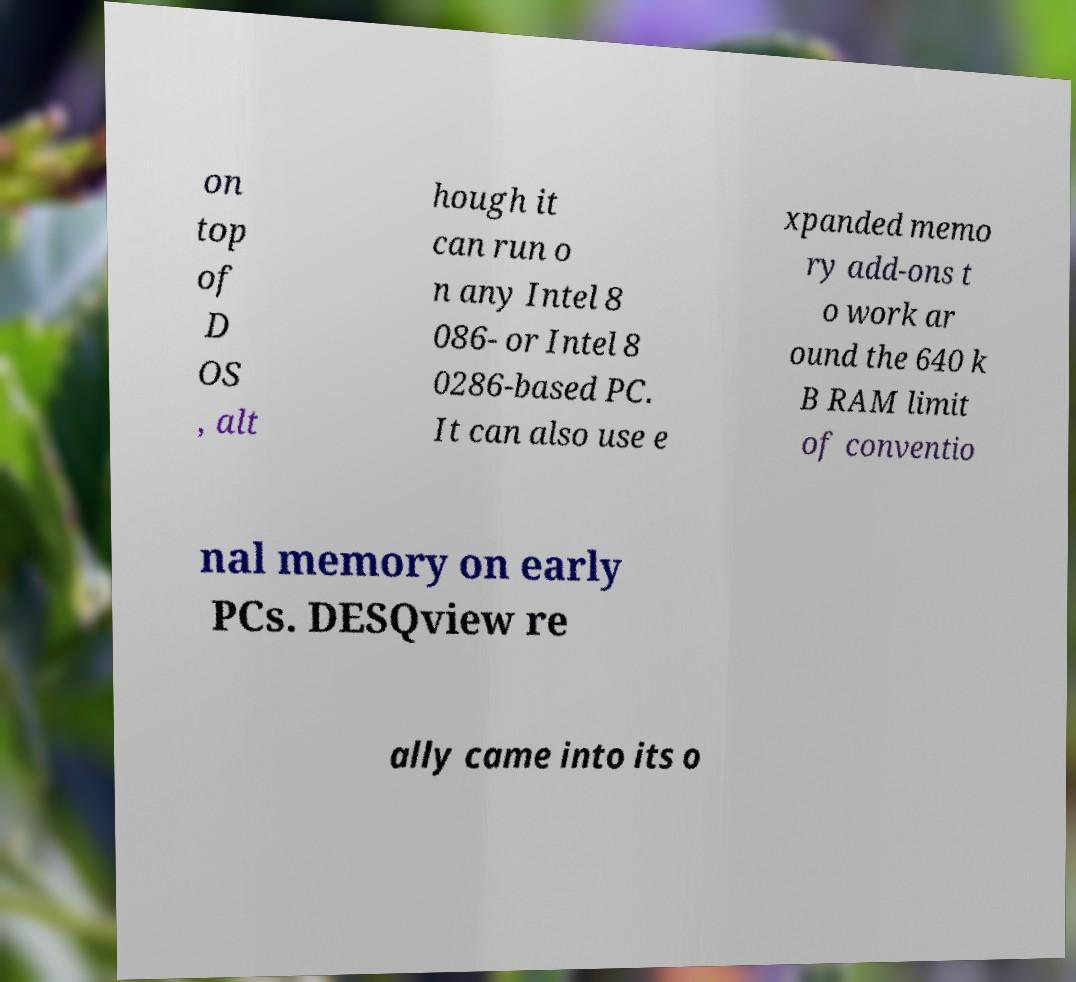What messages or text are displayed in this image? I need them in a readable, typed format. on top of D OS , alt hough it can run o n any Intel 8 086- or Intel 8 0286-based PC. It can also use e xpanded memo ry add-ons t o work ar ound the 640 k B RAM limit of conventio nal memory on early PCs. DESQview re ally came into its o 